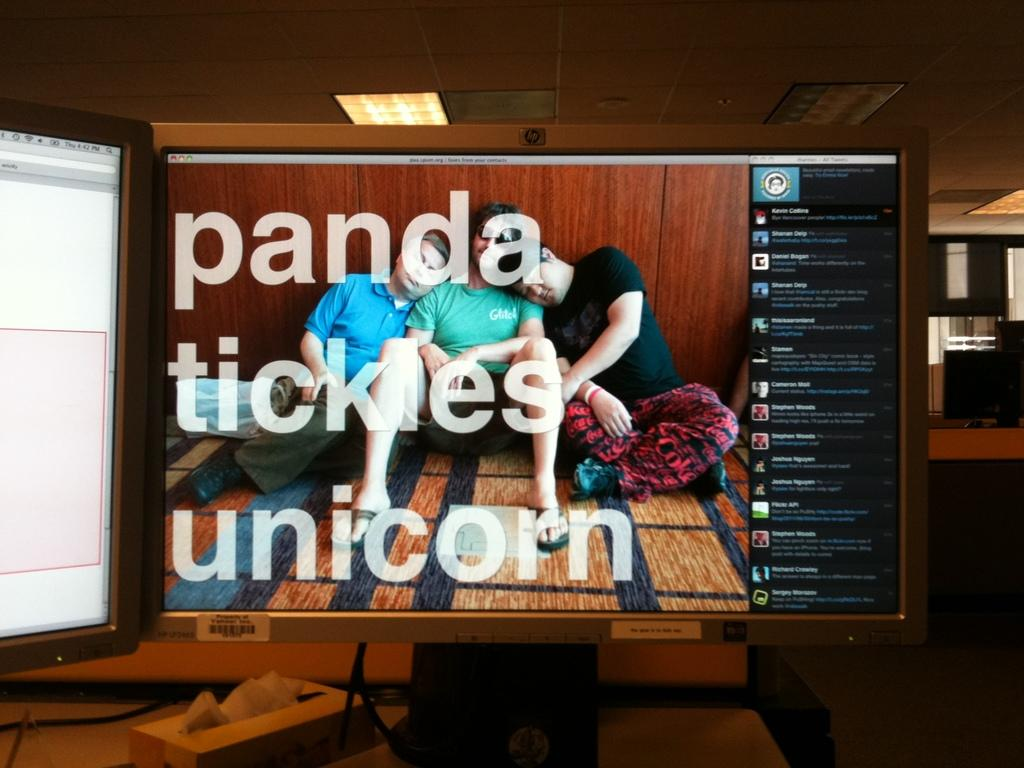Provide a one-sentence caption for the provided image. A monitor shows the words, "panda tickles unicorn.". 